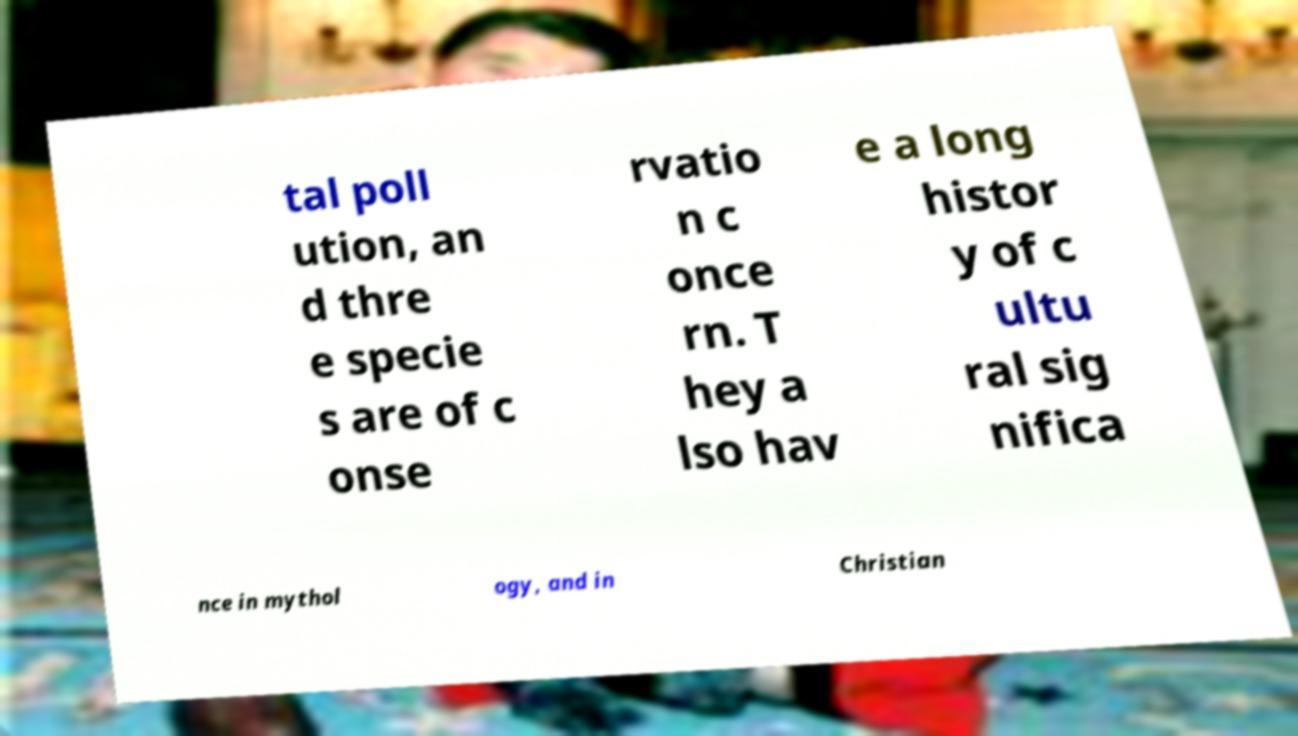Can you read and provide the text displayed in the image?This photo seems to have some interesting text. Can you extract and type it out for me? tal poll ution, an d thre e specie s are of c onse rvatio n c once rn. T hey a lso hav e a long histor y of c ultu ral sig nifica nce in mythol ogy, and in Christian 